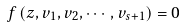<formula> <loc_0><loc_0><loc_500><loc_500>f \left ( z , v _ { 1 } , v _ { 2 } , \cdots , v _ { s + 1 } \right ) = 0</formula> 